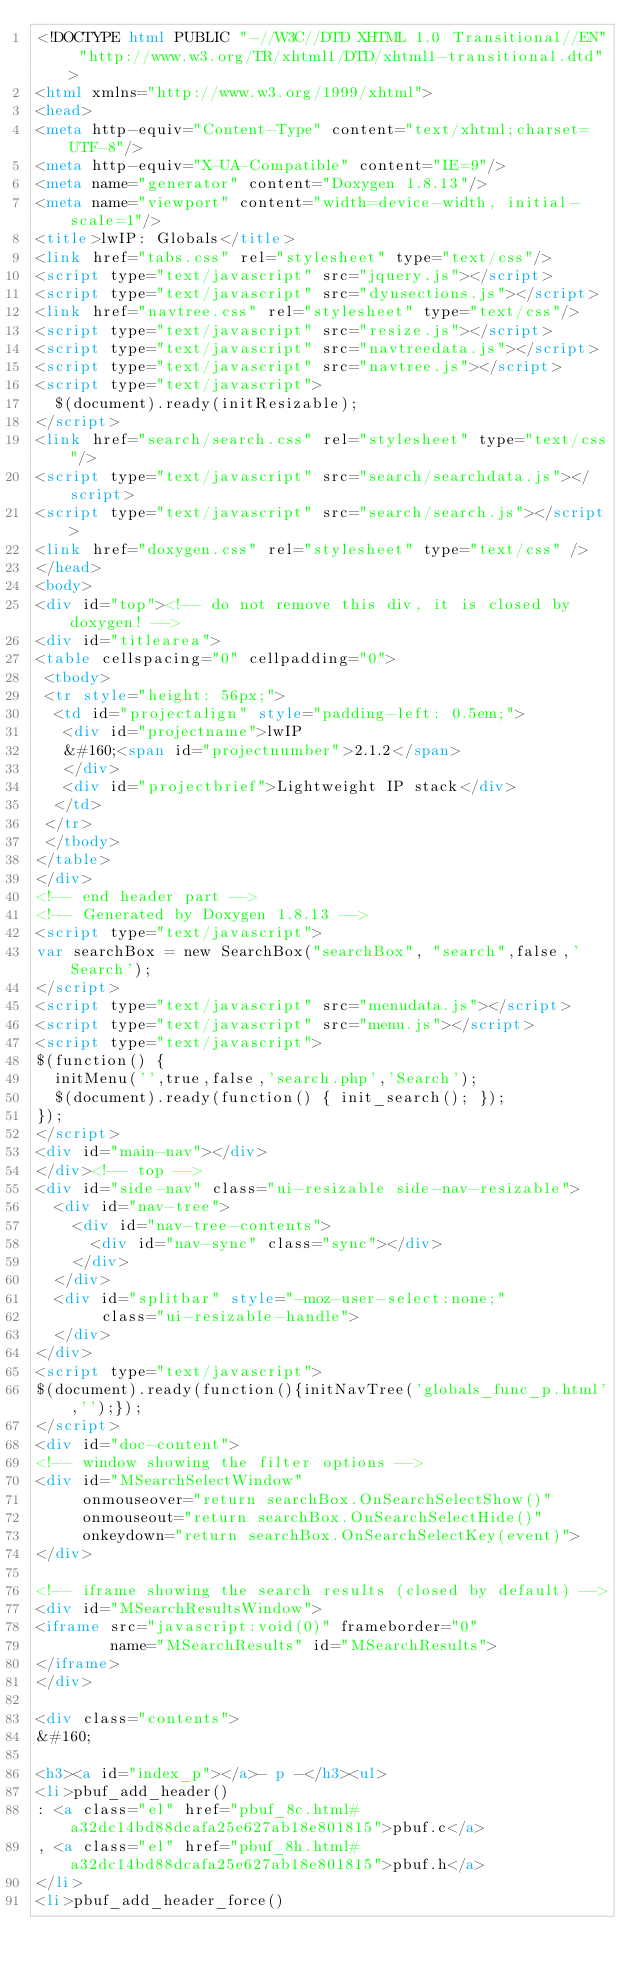<code> <loc_0><loc_0><loc_500><loc_500><_HTML_><!DOCTYPE html PUBLIC "-//W3C//DTD XHTML 1.0 Transitional//EN" "http://www.w3.org/TR/xhtml1/DTD/xhtml1-transitional.dtd">
<html xmlns="http://www.w3.org/1999/xhtml">
<head>
<meta http-equiv="Content-Type" content="text/xhtml;charset=UTF-8"/>
<meta http-equiv="X-UA-Compatible" content="IE=9"/>
<meta name="generator" content="Doxygen 1.8.13"/>
<meta name="viewport" content="width=device-width, initial-scale=1"/>
<title>lwIP: Globals</title>
<link href="tabs.css" rel="stylesheet" type="text/css"/>
<script type="text/javascript" src="jquery.js"></script>
<script type="text/javascript" src="dynsections.js"></script>
<link href="navtree.css" rel="stylesheet" type="text/css"/>
<script type="text/javascript" src="resize.js"></script>
<script type="text/javascript" src="navtreedata.js"></script>
<script type="text/javascript" src="navtree.js"></script>
<script type="text/javascript">
  $(document).ready(initResizable);
</script>
<link href="search/search.css" rel="stylesheet" type="text/css"/>
<script type="text/javascript" src="search/searchdata.js"></script>
<script type="text/javascript" src="search/search.js"></script>
<link href="doxygen.css" rel="stylesheet" type="text/css" />
</head>
<body>
<div id="top"><!-- do not remove this div, it is closed by doxygen! -->
<div id="titlearea">
<table cellspacing="0" cellpadding="0">
 <tbody>
 <tr style="height: 56px;">
  <td id="projectalign" style="padding-left: 0.5em;">
   <div id="projectname">lwIP
   &#160;<span id="projectnumber">2.1.2</span>
   </div>
   <div id="projectbrief">Lightweight IP stack</div>
  </td>
 </tr>
 </tbody>
</table>
</div>
<!-- end header part -->
<!-- Generated by Doxygen 1.8.13 -->
<script type="text/javascript">
var searchBox = new SearchBox("searchBox", "search",false,'Search');
</script>
<script type="text/javascript" src="menudata.js"></script>
<script type="text/javascript" src="menu.js"></script>
<script type="text/javascript">
$(function() {
  initMenu('',true,false,'search.php','Search');
  $(document).ready(function() { init_search(); });
});
</script>
<div id="main-nav"></div>
</div><!-- top -->
<div id="side-nav" class="ui-resizable side-nav-resizable">
  <div id="nav-tree">
    <div id="nav-tree-contents">
      <div id="nav-sync" class="sync"></div>
    </div>
  </div>
  <div id="splitbar" style="-moz-user-select:none;" 
       class="ui-resizable-handle">
  </div>
</div>
<script type="text/javascript">
$(document).ready(function(){initNavTree('globals_func_p.html','');});
</script>
<div id="doc-content">
<!-- window showing the filter options -->
<div id="MSearchSelectWindow"
     onmouseover="return searchBox.OnSearchSelectShow()"
     onmouseout="return searchBox.OnSearchSelectHide()"
     onkeydown="return searchBox.OnSearchSelectKey(event)">
</div>

<!-- iframe showing the search results (closed by default) -->
<div id="MSearchResultsWindow">
<iframe src="javascript:void(0)" frameborder="0" 
        name="MSearchResults" id="MSearchResults">
</iframe>
</div>

<div class="contents">
&#160;

<h3><a id="index_p"></a>- p -</h3><ul>
<li>pbuf_add_header()
: <a class="el" href="pbuf_8c.html#a32dc14bd88dcafa25e627ab18e801815">pbuf.c</a>
, <a class="el" href="pbuf_8h.html#a32dc14bd88dcafa25e627ab18e801815">pbuf.h</a>
</li>
<li>pbuf_add_header_force()</code> 